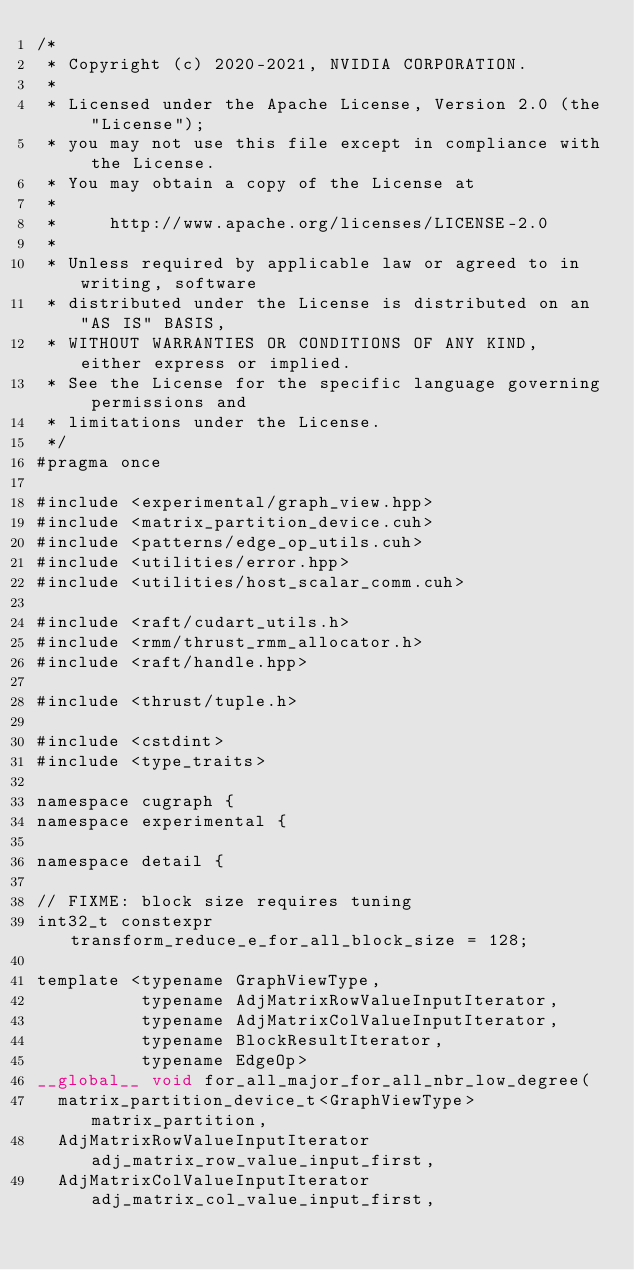<code> <loc_0><loc_0><loc_500><loc_500><_Cuda_>/*
 * Copyright (c) 2020-2021, NVIDIA CORPORATION.
 *
 * Licensed under the Apache License, Version 2.0 (the "License");
 * you may not use this file except in compliance with the License.
 * You may obtain a copy of the License at
 *
 *     http://www.apache.org/licenses/LICENSE-2.0
 *
 * Unless required by applicable law or agreed to in writing, software
 * distributed under the License is distributed on an "AS IS" BASIS,
 * WITHOUT WARRANTIES OR CONDITIONS OF ANY KIND, either express or implied.
 * See the License for the specific language governing permissions and
 * limitations under the License.
 */
#pragma once

#include <experimental/graph_view.hpp>
#include <matrix_partition_device.cuh>
#include <patterns/edge_op_utils.cuh>
#include <utilities/error.hpp>
#include <utilities/host_scalar_comm.cuh>

#include <raft/cudart_utils.h>
#include <rmm/thrust_rmm_allocator.h>
#include <raft/handle.hpp>

#include <thrust/tuple.h>

#include <cstdint>
#include <type_traits>

namespace cugraph {
namespace experimental {

namespace detail {

// FIXME: block size requires tuning
int32_t constexpr transform_reduce_e_for_all_block_size = 128;

template <typename GraphViewType,
          typename AdjMatrixRowValueInputIterator,
          typename AdjMatrixColValueInputIterator,
          typename BlockResultIterator,
          typename EdgeOp>
__global__ void for_all_major_for_all_nbr_low_degree(
  matrix_partition_device_t<GraphViewType> matrix_partition,
  AdjMatrixRowValueInputIterator adj_matrix_row_value_input_first,
  AdjMatrixColValueInputIterator adj_matrix_col_value_input_first,</code> 